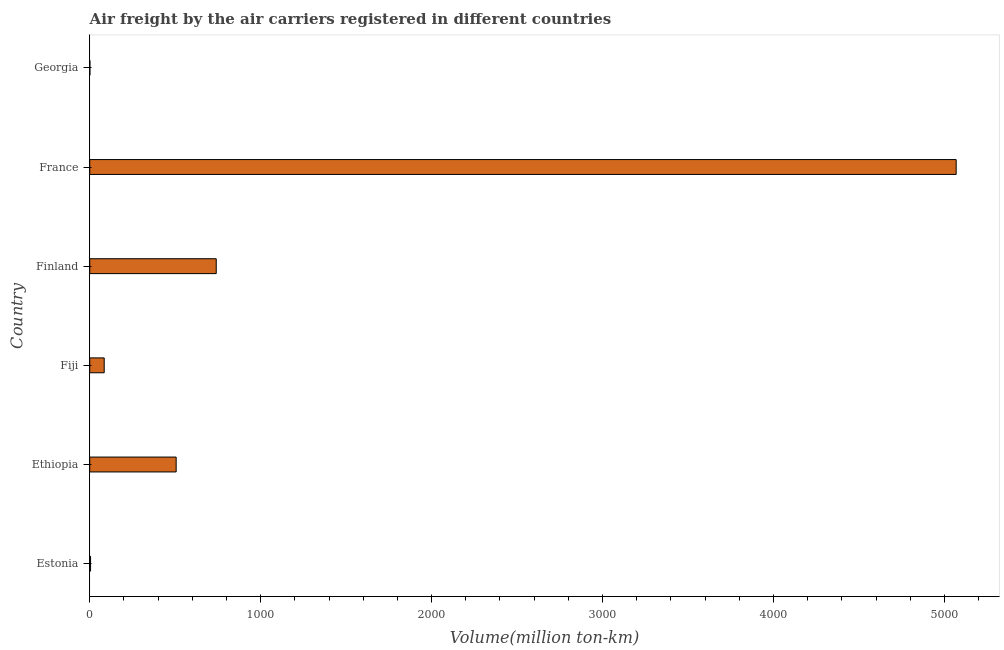Does the graph contain grids?
Make the answer very short. No. What is the title of the graph?
Provide a short and direct response. Air freight by the air carriers registered in different countries. What is the label or title of the X-axis?
Your answer should be compact. Volume(million ton-km). What is the label or title of the Y-axis?
Your answer should be very brief. Country. What is the air freight in France?
Offer a terse response. 5068.76. Across all countries, what is the maximum air freight?
Offer a terse response. 5068.76. Across all countries, what is the minimum air freight?
Ensure brevity in your answer.  0.93. In which country was the air freight maximum?
Keep it short and to the point. France. In which country was the air freight minimum?
Keep it short and to the point. Georgia. What is the sum of the air freight?
Give a very brief answer. 6404.85. What is the difference between the air freight in Ethiopia and Fiji?
Your answer should be compact. 420.92. What is the average air freight per country?
Give a very brief answer. 1067.48. What is the median air freight?
Your answer should be very brief. 295.1. In how many countries, is the air freight greater than 4200 million ton-km?
Provide a short and direct response. 1. What is the ratio of the air freight in France to that in Georgia?
Provide a short and direct response. 5456.15. Is the air freight in Finland less than that in France?
Ensure brevity in your answer.  Yes. What is the difference between the highest and the second highest air freight?
Your answer should be compact. 4328.68. Is the sum of the air freight in Finland and Georgia greater than the maximum air freight across all countries?
Offer a very short reply. No. What is the difference between the highest and the lowest air freight?
Your answer should be compact. 5067.83. How many countries are there in the graph?
Provide a short and direct response. 6. What is the difference between two consecutive major ticks on the X-axis?
Make the answer very short. 1000. Are the values on the major ticks of X-axis written in scientific E-notation?
Your answer should be compact. No. What is the Volume(million ton-km) in Estonia?
Your answer should be very brief. 4.87. What is the Volume(million ton-km) of Ethiopia?
Offer a very short reply. 505.56. What is the Volume(million ton-km) in Fiji?
Offer a very short reply. 84.64. What is the Volume(million ton-km) in Finland?
Make the answer very short. 740.09. What is the Volume(million ton-km) in France?
Provide a succinct answer. 5068.76. What is the Volume(million ton-km) in Georgia?
Give a very brief answer. 0.93. What is the difference between the Volume(million ton-km) in Estonia and Ethiopia?
Provide a succinct answer. -500.69. What is the difference between the Volume(million ton-km) in Estonia and Fiji?
Make the answer very short. -79.77. What is the difference between the Volume(million ton-km) in Estonia and Finland?
Keep it short and to the point. -735.21. What is the difference between the Volume(million ton-km) in Estonia and France?
Your answer should be very brief. -5063.89. What is the difference between the Volume(million ton-km) in Estonia and Georgia?
Provide a succinct answer. 3.94. What is the difference between the Volume(million ton-km) in Ethiopia and Fiji?
Offer a terse response. 420.92. What is the difference between the Volume(million ton-km) in Ethiopia and Finland?
Ensure brevity in your answer.  -234.52. What is the difference between the Volume(million ton-km) in Ethiopia and France?
Your response must be concise. -4563.2. What is the difference between the Volume(million ton-km) in Ethiopia and Georgia?
Provide a short and direct response. 504.64. What is the difference between the Volume(million ton-km) in Fiji and Finland?
Offer a terse response. -655.44. What is the difference between the Volume(million ton-km) in Fiji and France?
Make the answer very short. -4984.12. What is the difference between the Volume(million ton-km) in Fiji and Georgia?
Keep it short and to the point. 83.71. What is the difference between the Volume(million ton-km) in Finland and France?
Give a very brief answer. -4328.68. What is the difference between the Volume(million ton-km) in Finland and Georgia?
Offer a terse response. 739.16. What is the difference between the Volume(million ton-km) in France and Georgia?
Offer a terse response. 5067.83. What is the ratio of the Volume(million ton-km) in Estonia to that in Ethiopia?
Provide a short and direct response. 0.01. What is the ratio of the Volume(million ton-km) in Estonia to that in Fiji?
Ensure brevity in your answer.  0.06. What is the ratio of the Volume(million ton-km) in Estonia to that in Finland?
Provide a succinct answer. 0.01. What is the ratio of the Volume(million ton-km) in Estonia to that in France?
Offer a very short reply. 0. What is the ratio of the Volume(million ton-km) in Estonia to that in Georgia?
Your response must be concise. 5.24. What is the ratio of the Volume(million ton-km) in Ethiopia to that in Fiji?
Keep it short and to the point. 5.97. What is the ratio of the Volume(million ton-km) in Ethiopia to that in Finland?
Provide a short and direct response. 0.68. What is the ratio of the Volume(million ton-km) in Ethiopia to that in Georgia?
Offer a terse response. 544.2. What is the ratio of the Volume(million ton-km) in Fiji to that in Finland?
Offer a terse response. 0.11. What is the ratio of the Volume(million ton-km) in Fiji to that in France?
Make the answer very short. 0.02. What is the ratio of the Volume(million ton-km) in Fiji to that in Georgia?
Provide a succinct answer. 91.11. What is the ratio of the Volume(million ton-km) in Finland to that in France?
Give a very brief answer. 0.15. What is the ratio of the Volume(million ton-km) in Finland to that in Georgia?
Keep it short and to the point. 796.65. What is the ratio of the Volume(million ton-km) in France to that in Georgia?
Provide a succinct answer. 5456.15. 